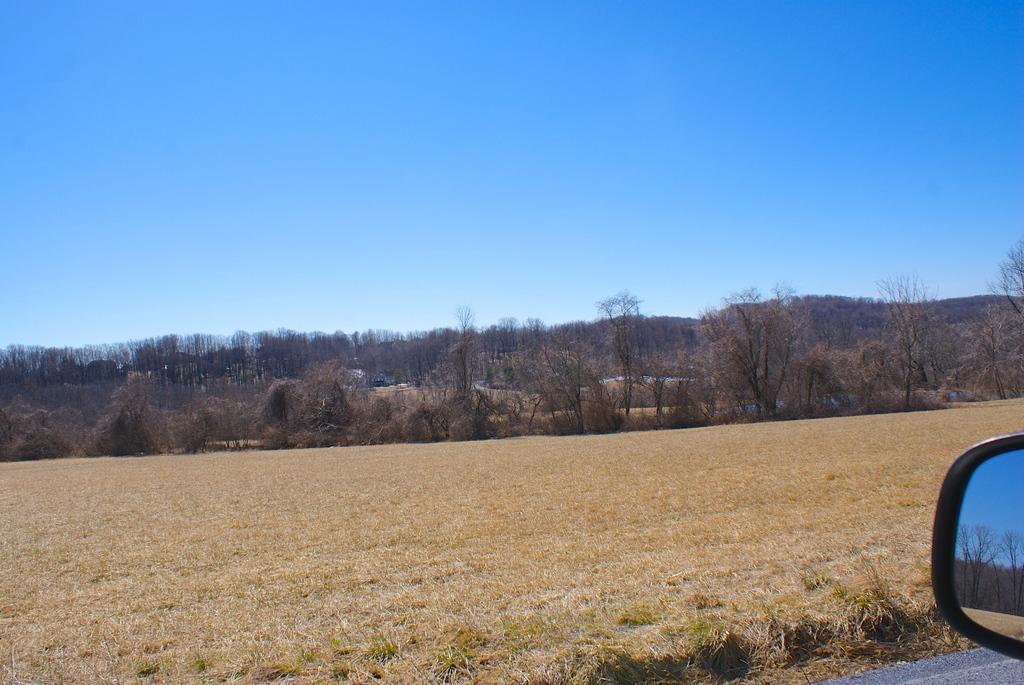Please provide a concise description of this image. This is mirror, these are trees and plants, this is sky. 